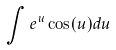<formula> <loc_0><loc_0><loc_500><loc_500>\int e ^ { u } \cos ( u ) d u</formula> 